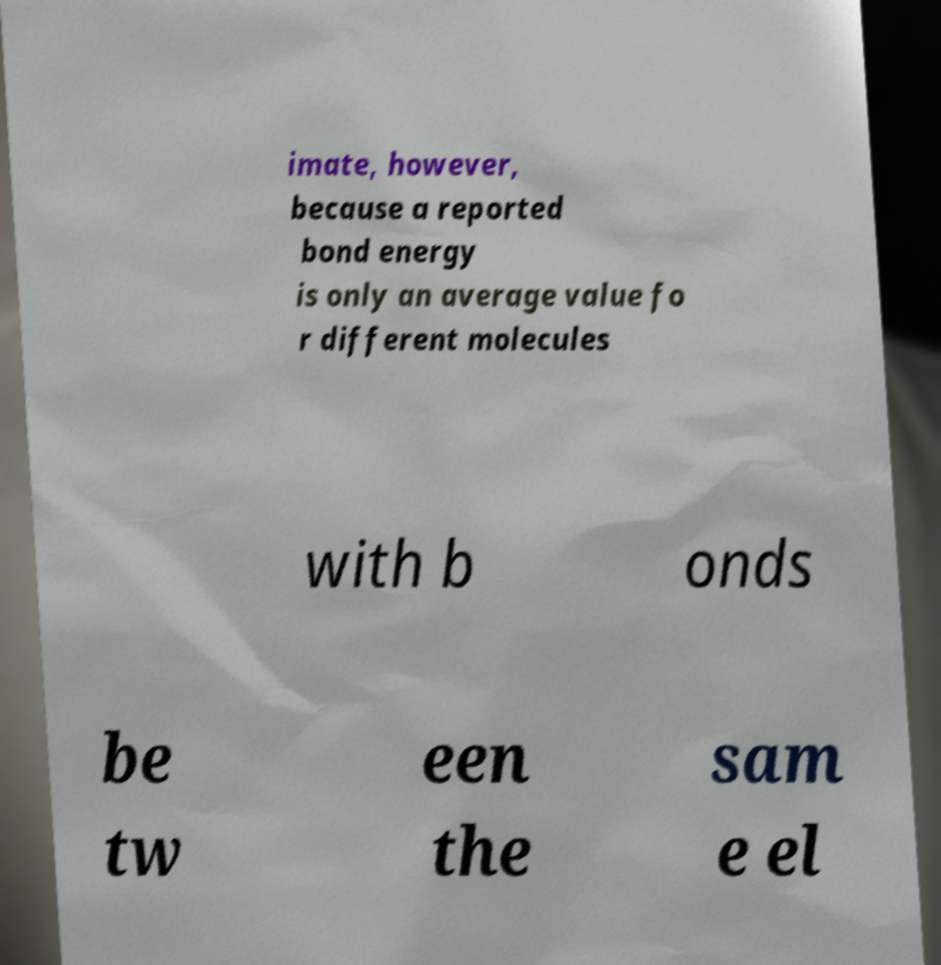Please identify and transcribe the text found in this image. imate, however, because a reported bond energy is only an average value fo r different molecules with b onds be tw een the sam e el 